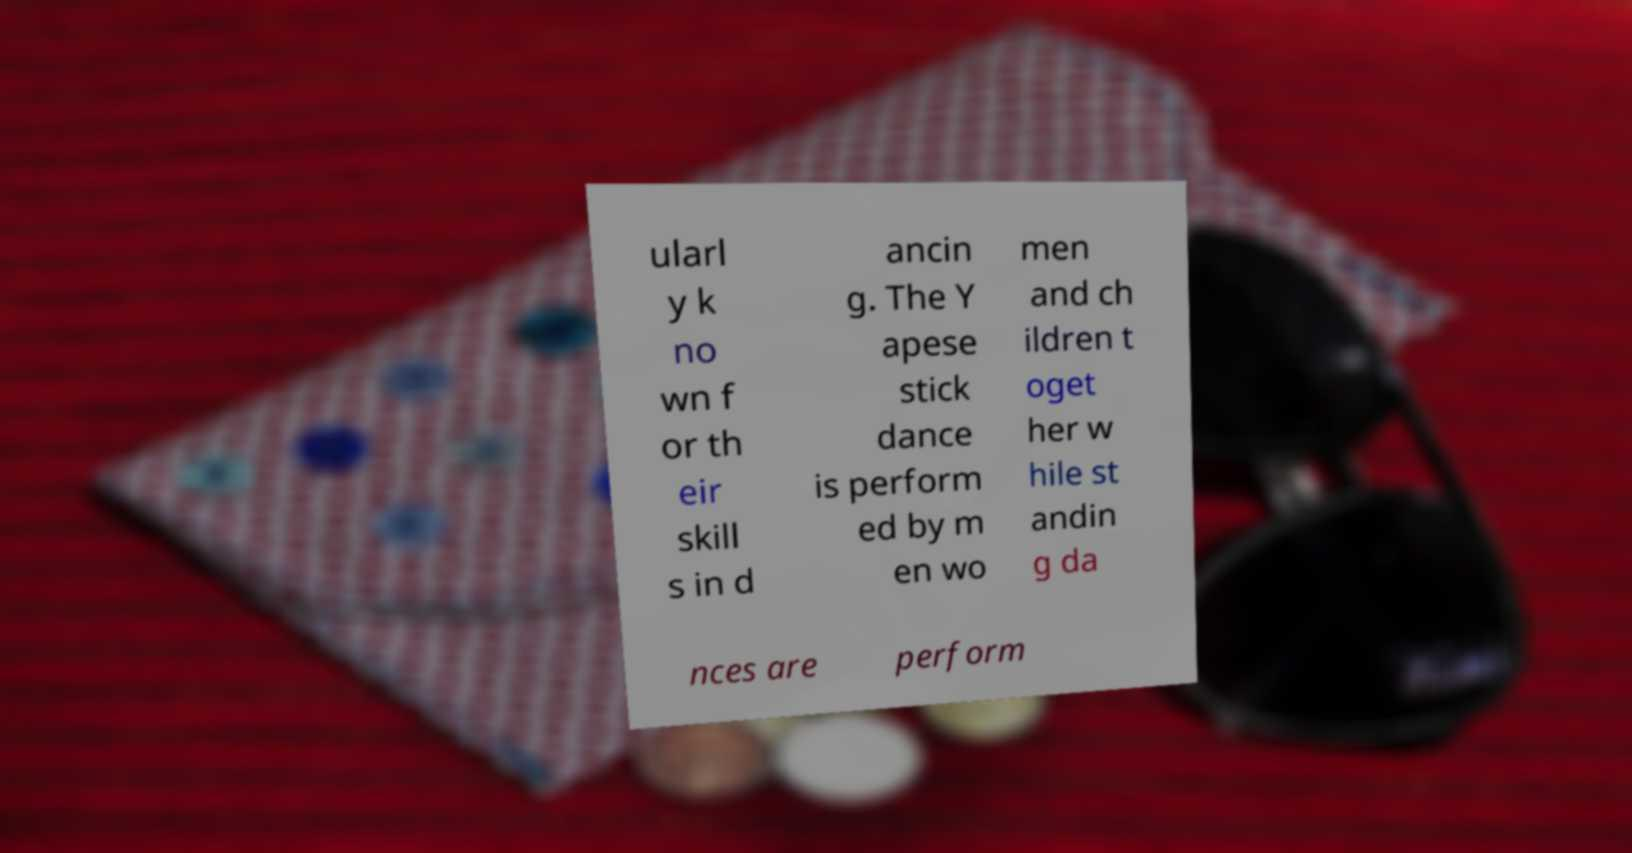Please read and relay the text visible in this image. What does it say? ularl y k no wn f or th eir skill s in d ancin g. The Y apese stick dance is perform ed by m en wo men and ch ildren t oget her w hile st andin g da nces are perform 